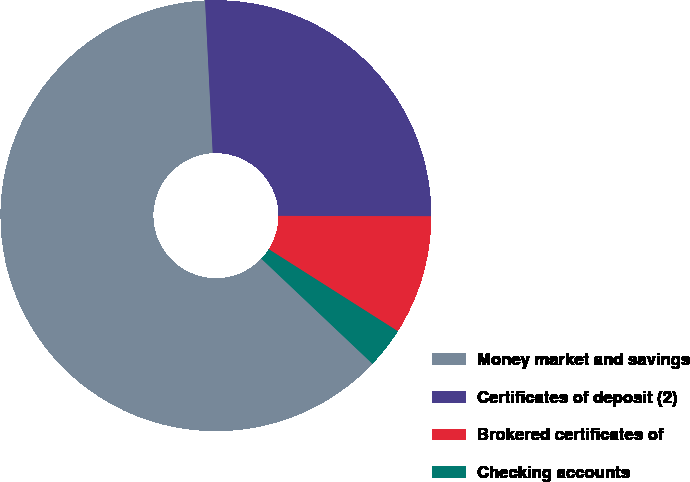Convert chart to OTSL. <chart><loc_0><loc_0><loc_500><loc_500><pie_chart><fcel>Money market and savings<fcel>Certificates of deposit (2)<fcel>Brokered certificates of<fcel>Checking accounts<nl><fcel>62.14%<fcel>25.85%<fcel>8.96%<fcel>3.05%<nl></chart> 